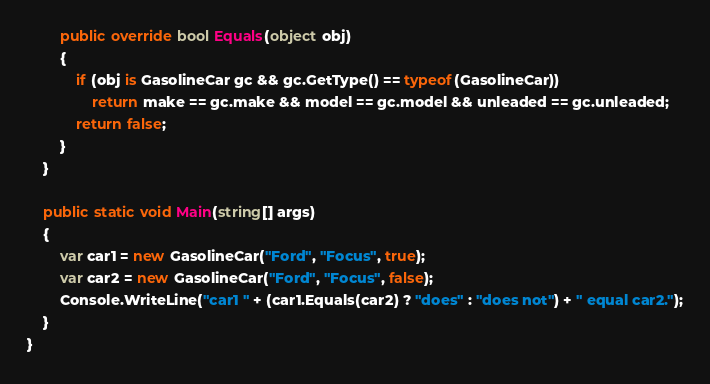Convert code to text. <code><loc_0><loc_0><loc_500><loc_500><_C#_>
        public override bool Equals(object obj)
        {
            if (obj is GasolineCar gc && gc.GetType() == typeof(GasolineCar))
                return make == gc.make && model == gc.model && unleaded == gc.unleaded;
            return false;
        }
    }

    public static void Main(string[] args)
    {
        var car1 = new GasolineCar("Ford", "Focus", true);
        var car2 = new GasolineCar("Ford", "Focus", false);
        Console.WriteLine("car1 " + (car1.Equals(car2) ? "does" : "does not") + " equal car2.");
    }
}
</code> 